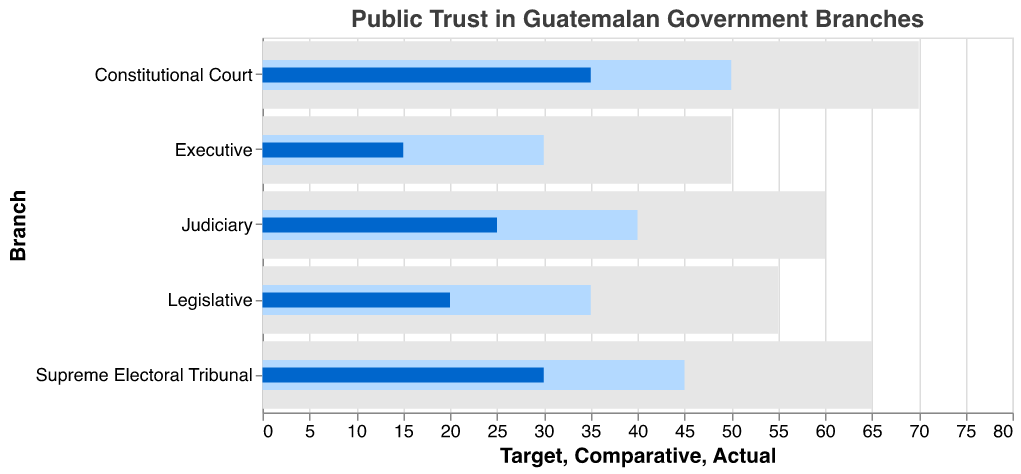What's the title of the figure? The title of the figure is located at the top and reads "Public Trust in Guatemalan Government Branches".
Answer: Public Trust in Guatemalan Government Branches Which branch has the highest actual public trust? Locate the bar with the darkest color (Actual) that extends the furthest to the right. It is marked "Constitutional Court".
Answer: Constitutional Court How does the actual trust in the Executive compare to its target? Compare the length of the darkest colored bar (Actual) for the Executive to the longest bar (Target) for the same branch.
Answer: 35 points below What is the target level of trust for the Supreme Electoral Tribunal? Identify the longest bar for the Supreme Electoral Tribunal, which represents the target trust level.
Answer: 65 Which branches exceed 30% in actual public trust? Look at the darkest bars (Actual) and identify those extending beyond the 30 mark. Only the Constitutional Court and Supreme Electoral Tribunal exceed this.
Answer: Constitutional Court, Supreme Electoral Tribunal What is the average actual trust level across all branches? Sum the actual trust values (15 + 20 + 25 + 30 + 35) to get 125. Divide by the number of branches (5).
Answer: 25 By how much does the Constitutional Court's actual trust exceed the Executive's comparative trust? Identify the values: Constitutional Court's actual is 35, Executive's comparative is 30. Subtract 30 from 35.
Answer: 5 Which branch has the smallest difference between comparative trust and the target? Calculate the differences for each branch (Executive: 20, Legislative: 20, Judiciary: 20, Supreme Electoral Tribunal: 20, Constitutional Court: 20). All branches have the same difference.
Answer: All branches equally What is the median comparative trust value? List the comparative trust values (30, 35, 40, 45, 50). The middle value is 40.
Answer: 40 